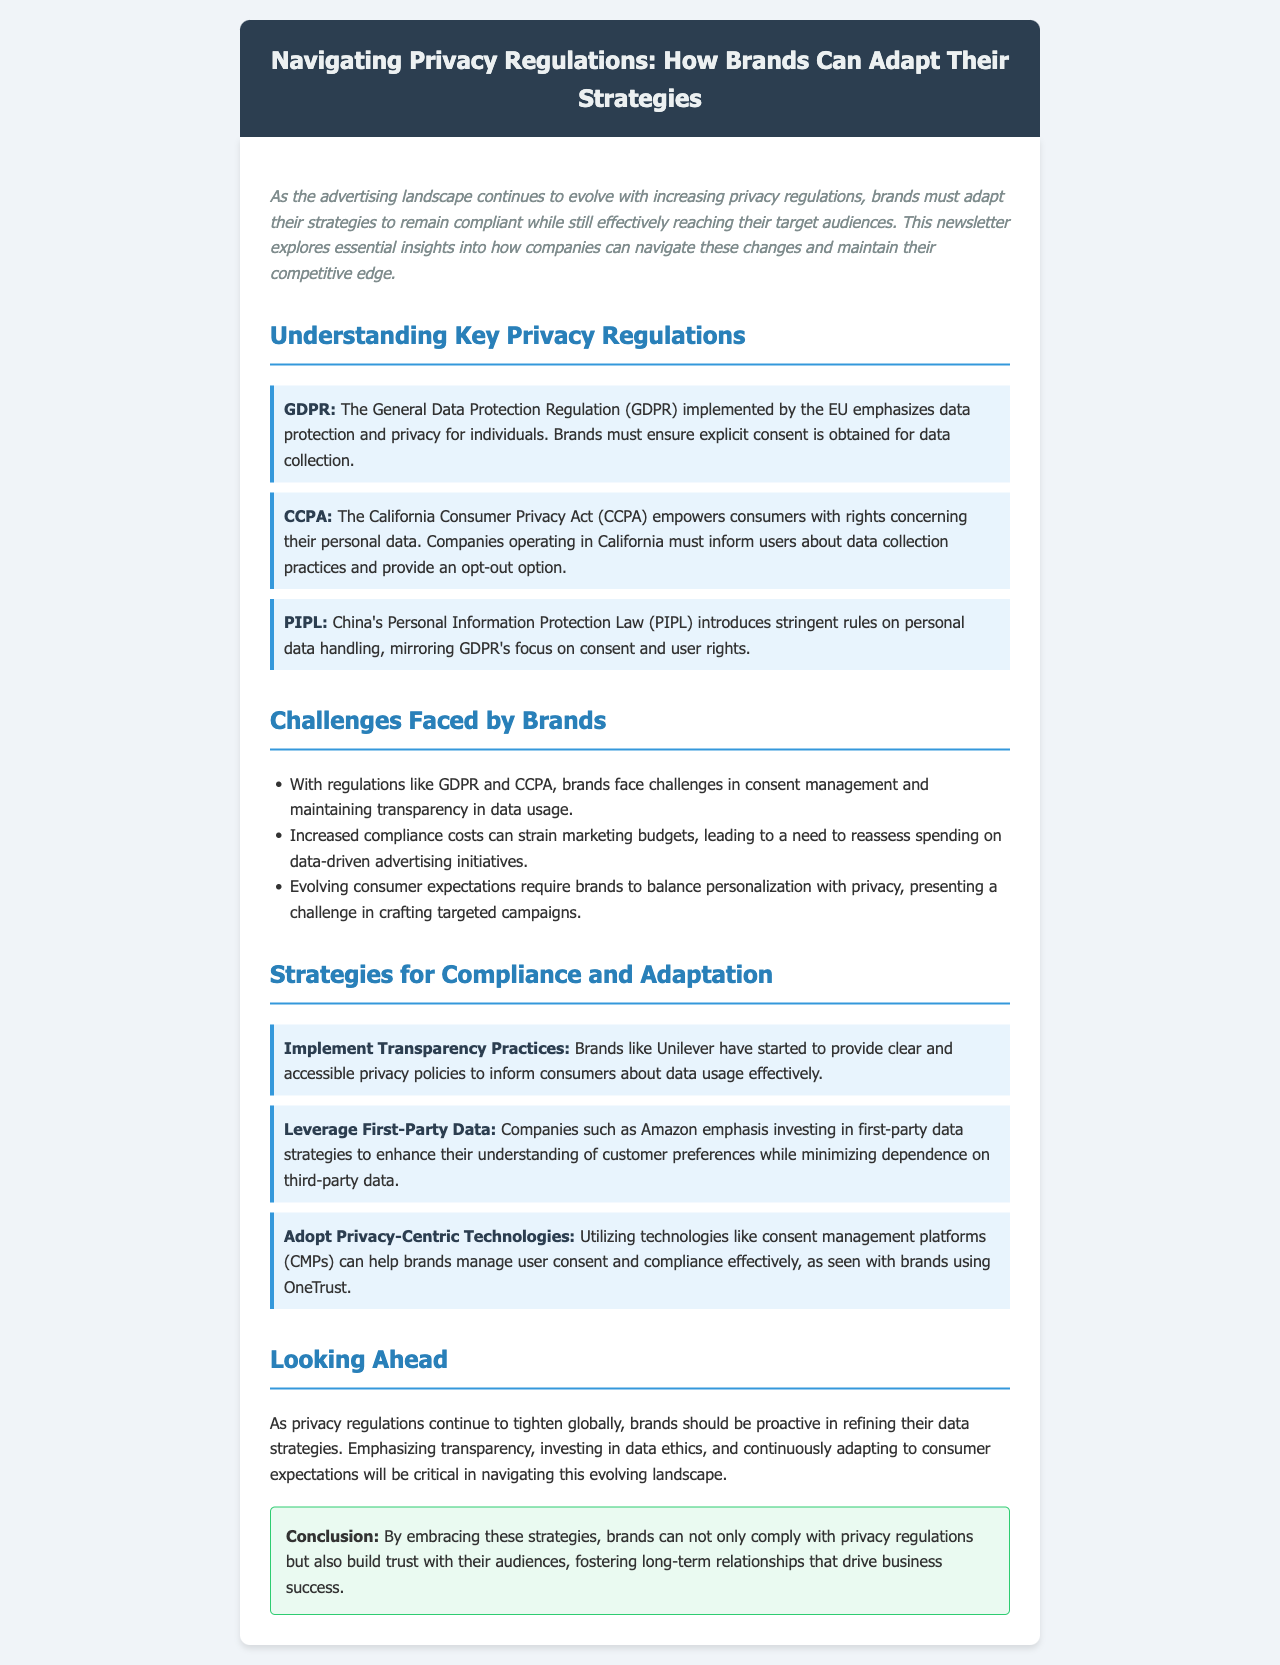What is GDPR? GDPR stands for General Data Protection Regulation, which emphasizes data protection and privacy for individuals.
Answer: General Data Protection Regulation What does CCPA empower consumers to do? CCPA empowers consumers with rights concerning their personal data, including opting out of data collection.
Answer: Opt-out Which company is mentioned for implementing transparency practices? Unilever is specifically mentioned for providing clear and accessible privacy policies.
Answer: Unilever What type of data does Amazon emphasize investing in? Amazon emphasizes investing in first-party data strategies to enhance customer understanding.
Answer: First-party data What challenge is associated with regulations like GDPR and CCPA? Brands face challenges in consent management and maintaining transparency in data usage due to these regulations.
Answer: Consent management How should brands refine their data strategies according to the newsletter? Brands should refine their data strategies by emphasizing transparency and investing in data ethics.
Answer: Emphasizing transparency What is OneTrust used for? OneTrust is utilized by brands for managing user consent and compliance effectively.
Answer: Manage user consent What is the primary focus of PIPL? PIPL focuses on personal data handling, emphasizing consent and user rights similar to GDPR.
Answer: Consent and user rights 